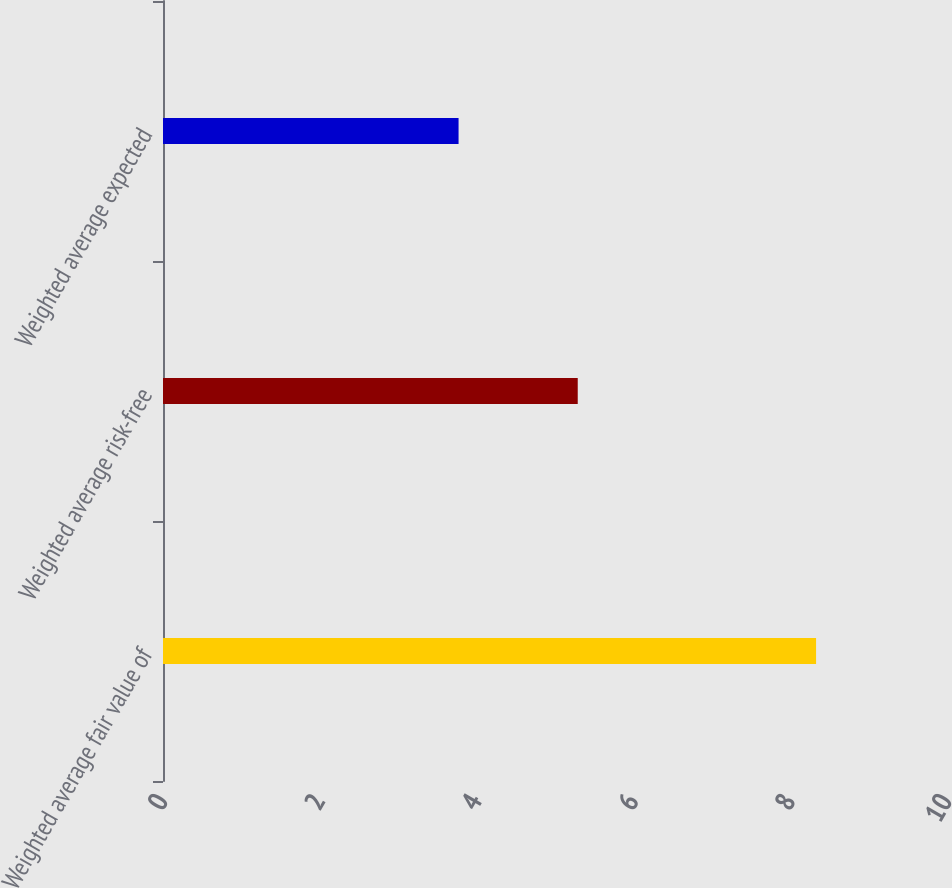Convert chart to OTSL. <chart><loc_0><loc_0><loc_500><loc_500><bar_chart><fcel>Weighted average fair value of<fcel>Weighted average risk-free<fcel>Weighted average expected<nl><fcel>8.33<fcel>5.29<fcel>3.77<nl></chart> 